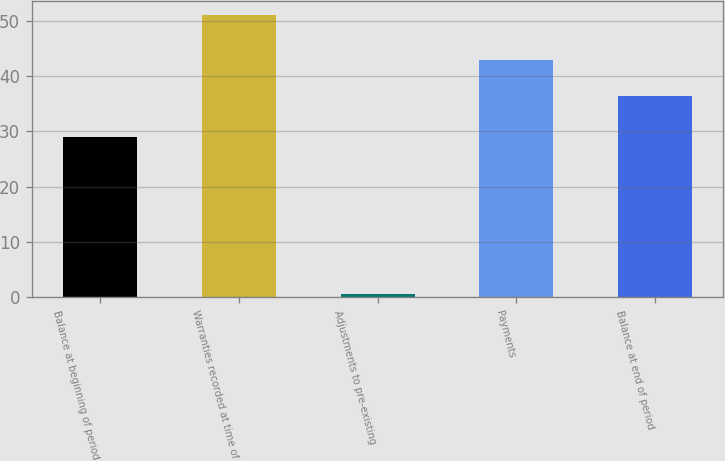<chart> <loc_0><loc_0><loc_500><loc_500><bar_chart><fcel>Balance at beginning of period<fcel>Warranties recorded at time of<fcel>Adjustments to pre-existing<fcel>Payments<fcel>Balance at end of period<nl><fcel>28.9<fcel>51<fcel>0.7<fcel>42.9<fcel>36.3<nl></chart> 